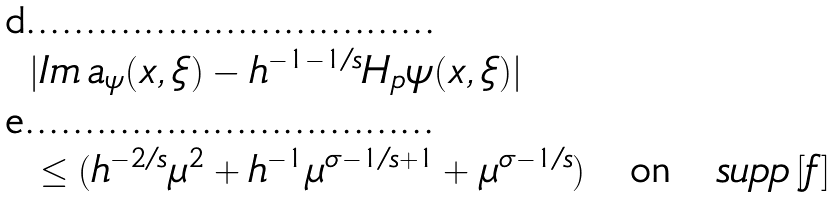Convert formula to latex. <formula><loc_0><loc_0><loc_500><loc_500>& | I m \, a _ { \psi } ( x , \xi ) - h ^ { - 1 - 1 / s } H _ { p } \psi ( x , \xi ) | \\ & \leq ( h ^ { - 2 / s } \mu ^ { 2 } + h ^ { - 1 } \mu ^ { \sigma - 1 / s + 1 } + \mu ^ { \sigma - 1 / s } ) \quad \text {on} \quad s u p p \, [ f ]</formula> 